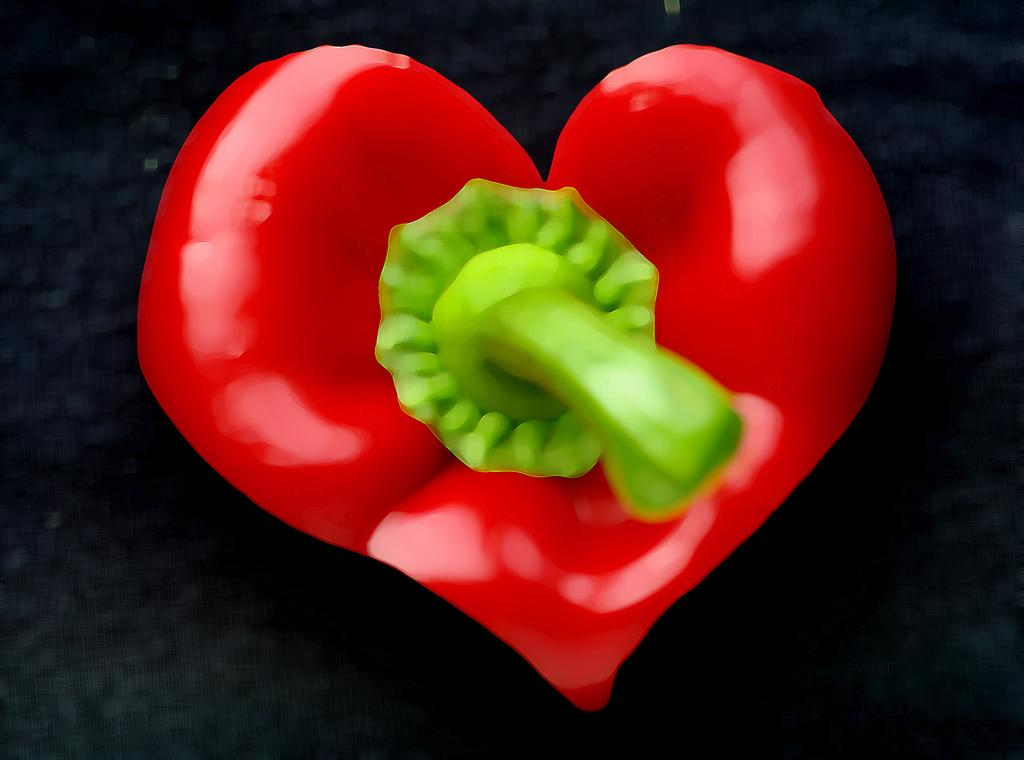What is the main subject of the image? There is a pepper heart in the image. What color is the background of the image? The background of the image is black. Reasoning: Let's think step by identifying the main subject and the background color from the provided facts. We start by mentioning the pepper heart as the main subject and then describe the black background. We avoid any assumptions or speculations and stick to the facts given. Absurd Question/Answer: Can you tell me how many lamps are connected to the pepper heart in the image? There are no lamps present in the image, and the pepper heart is not connected to any lamps. 